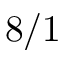Convert formula to latex. <formula><loc_0><loc_0><loc_500><loc_500>8 / 1</formula> 